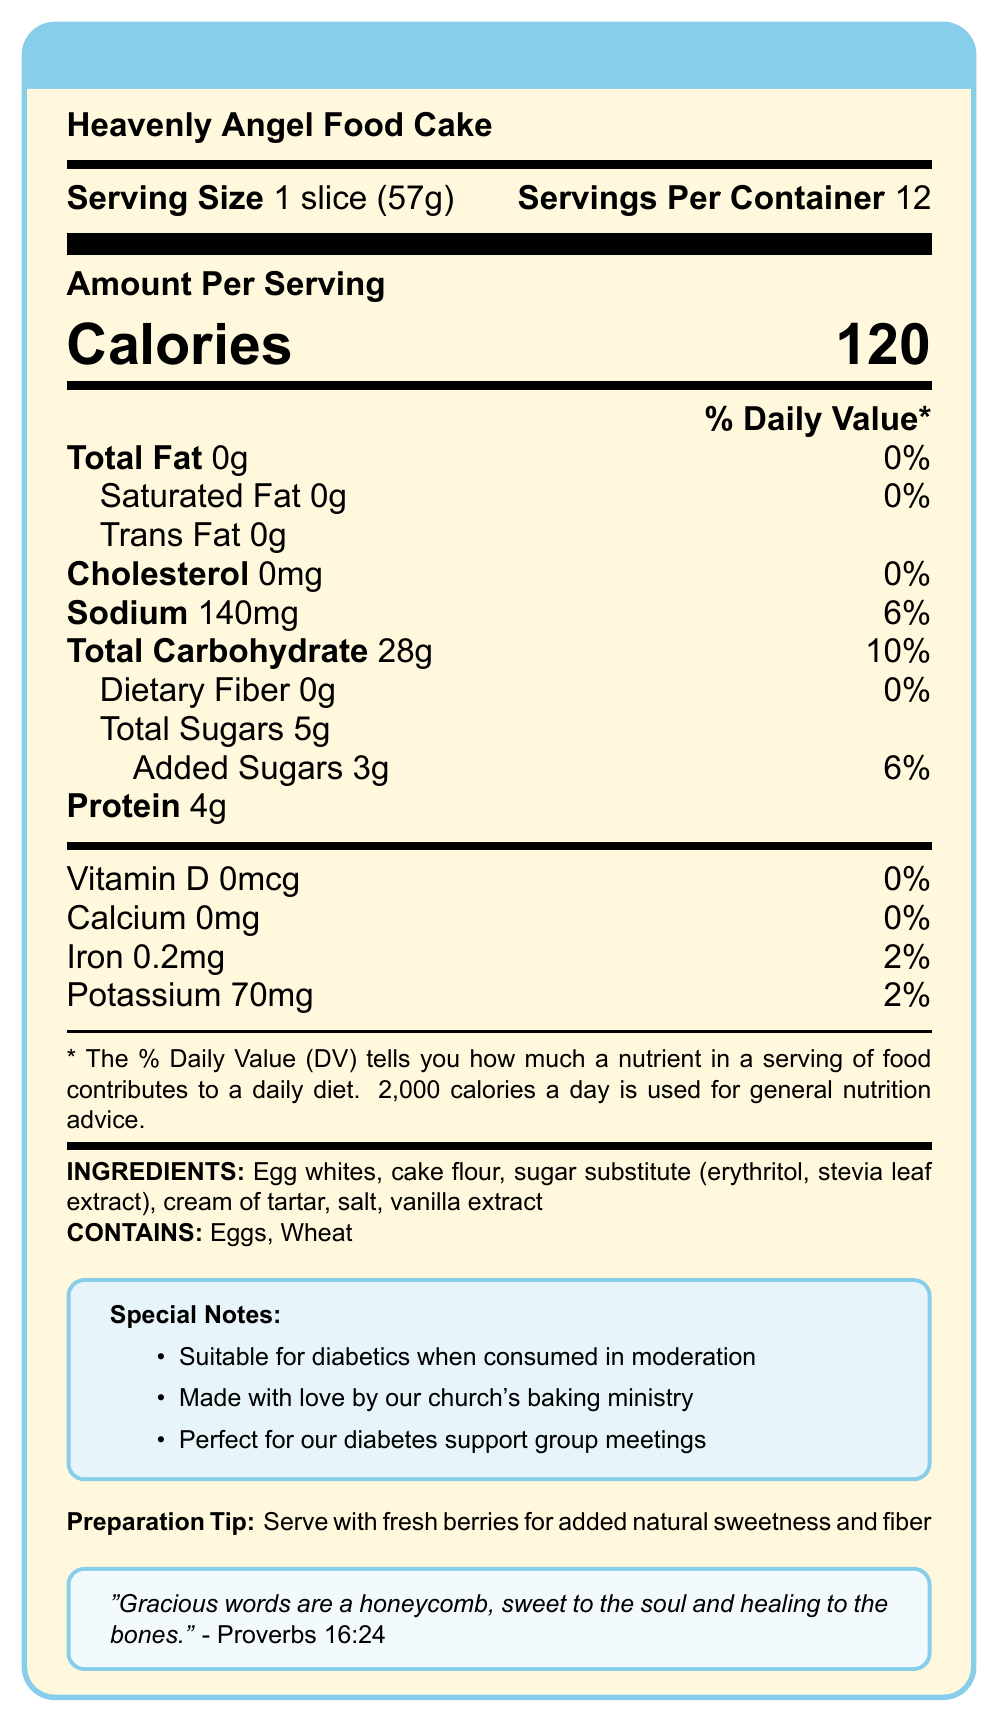what is the serving size of the Heavenly Angel Food Cake? The serving size is listed at the beginning of the Nutrition Facts label.
Answer: 1 slice (57g) how many servings are in one container of the Heavenly Angel Food Cake? The document states there are 12 servings per container.
Answer: 12 how many grams of added sugars are in one serving? Under Total Sugars, it is mentioned that there are 3 grams of added sugars.
Answer: 3g is this cake suitable for people with diabetes? The special notes indicate that it is suitable for diabetics when consumed in moderation.
Answer: Yes what is the amount of total fat in one slice? The Total Fat amount is listed as 0g per serving.
Answer: 0g which of the following nutrients is not present in the Heavenly Angel Food Cake? A. Protein B. Dietary Fiber C. Iron D. Carbohydrates The cake contains Protein, Iron, and Carbohydrates but has 0g of Dietary Fiber.
Answer: B how many calories are in one serving? The label shows that there are 120 calories per serving.
Answer: 120 what is the percent daily value of sodium per serving? The percent daily value of sodium per serving is given as 6%.
Answer: 6% what are the main ingredients in the cake? A. Sugar, cake flour, eggs, and cream of tartar B. Egg yolks, butter, sugar, and vanilla C. Egg whites, cake flour, sugar substitute, and vanilla extract The document lists the ingredients as egg whites, cake flour, sugar substitute, cream of tartar, salt, and vanilla extract.
Answer: C does the cake contain any allergens? The allergens section states that the cake contains eggs and wheat.
Answer: Yes what is a recommended way to serve the cake for added natural sweetness and fiber? The preparation tips suggest serving with fresh berries.
Answer: With fresh berries what verse from the scripture is included in the document? The document includes the verse: "Gracious words are a honeycomb, sweet to the soul and healing to the bones." - Proverbs 16:24.
Answer: Proverbs 16:24 is there any calcium in the cake? The label shows that calcium is 0mg, which is 0% of the daily value.
Answer: No what special notes are given about the cake? The special notes section lists these points.
Answer: Suitable for diabetics when consumed in moderation; Made with love by our church's baking ministry; Perfect for our diabetes support group meetings summarize the information provided in the document. The summary includes details about the nutritional content, suitability for diabetics, main ingredients, allergens, preparation suggestions, and an inspirational scripture verse.
Answer: The document provides the Nutrition Facts for the Heavenly Angel Food Cake, indicating it is low in fat and suitable for diabetics. It lists the ingredients, allergens, preparation tips, and contains a scripture verse. how many grams of protein does one serving of the cake provide? The label states there are 4g of protein per serving.
Answer: 4g who made the Heavenly Angel Food Cake? The special notes mention that it is made with love by the church's baking ministry.
Answer: Church's baking ministry is this dessert completely free from any sugars? The dessert contains 5g of total sugars, of which 3g are added sugars.
Answer: No are there any preservatives listed in the ingredients? The ingredients listed do not include any preservatives.
Answer: No how much potassium is in one serving of the cake? The document lists 70mg of potassium, which is 2% of the daily value.
Answer: 70mg what is the amount of dietary fiber in one slice? The label shows 0g of dietary fiber per serving.
Answer: 0g what health benefit is claimed in the scripture included in the document? A. Bone strength B. Heart health C. Mental clarity The scripture talks about gracious words being healing to the bones.
Answer: A how many milligrams of cholesterol does one serving contain? The label indicates that one serving contains 0mg of cholesterol.
Answer: 0mg 